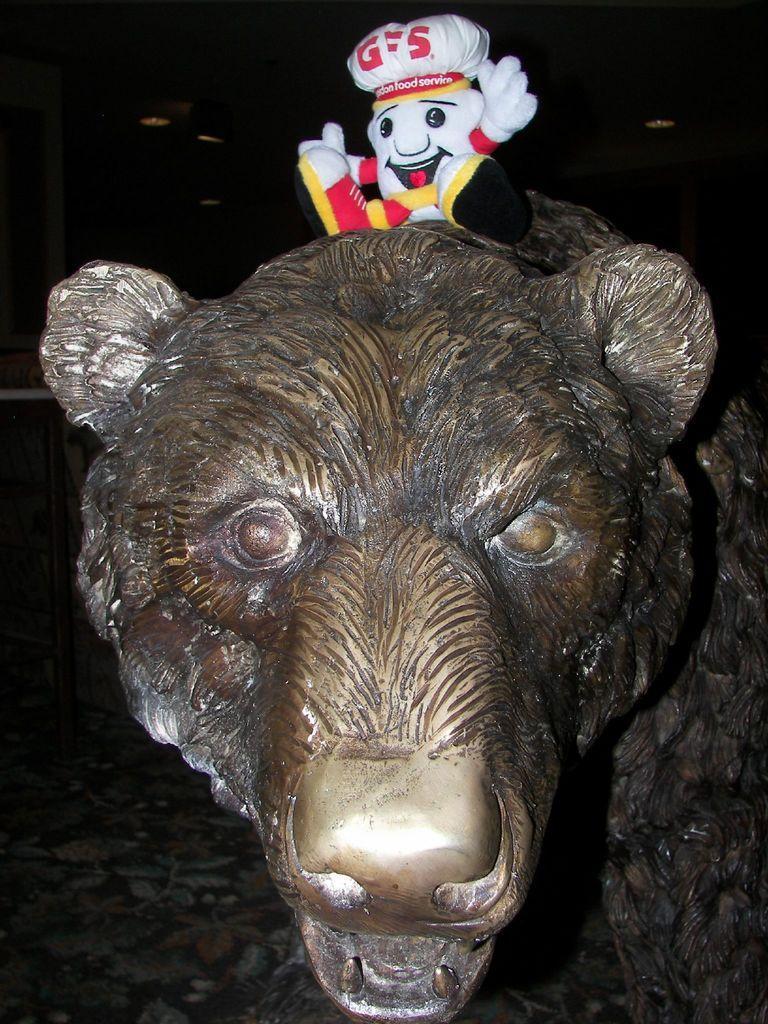Please provide a concise description of this image. In this picture we can see the metal tiger statue in the front. On the top there is a small toy teddy bear. Behind there is a dark background. 